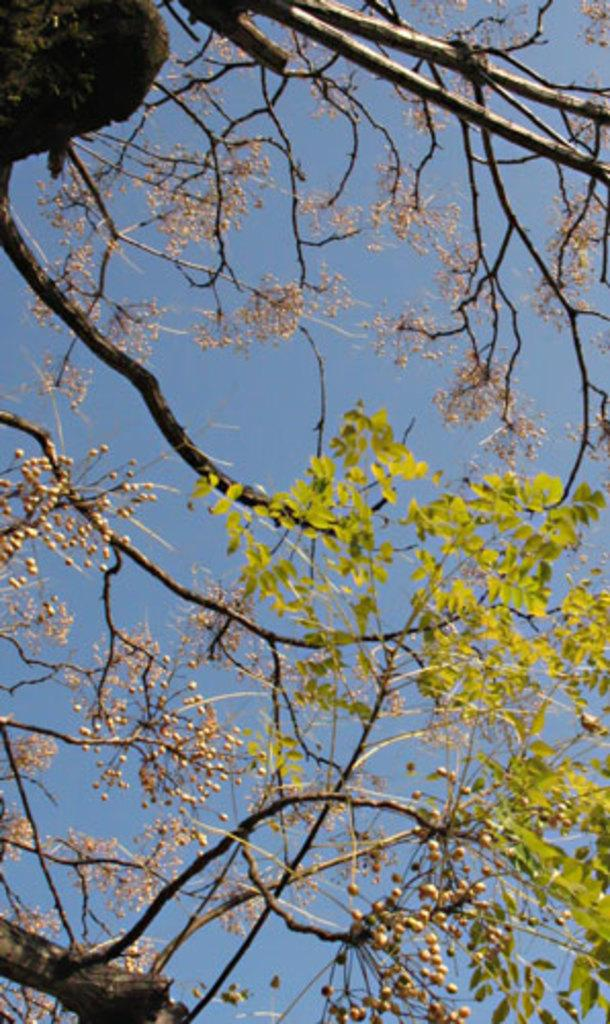What type of plant can be seen in the image? There is a tree in the image. What part of the natural environment is visible in the image? The sky is visible in the image. What type of journey does the turkey take in the image? There is no turkey present in the image, so it is not possible to answer that question. 